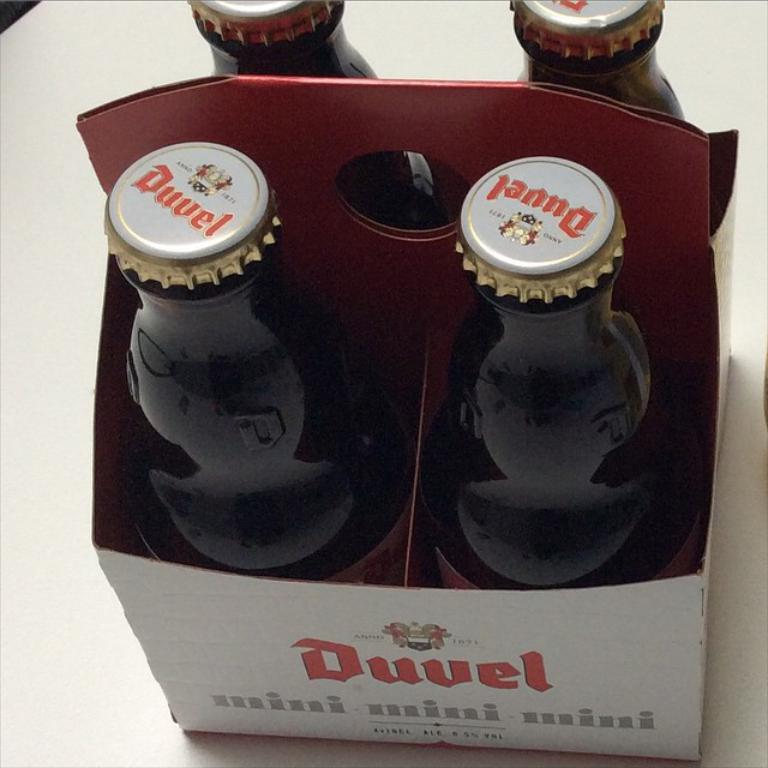<image>
Offer a succinct explanation of the picture presented. A bottle of Duvel beer rests on a white table 